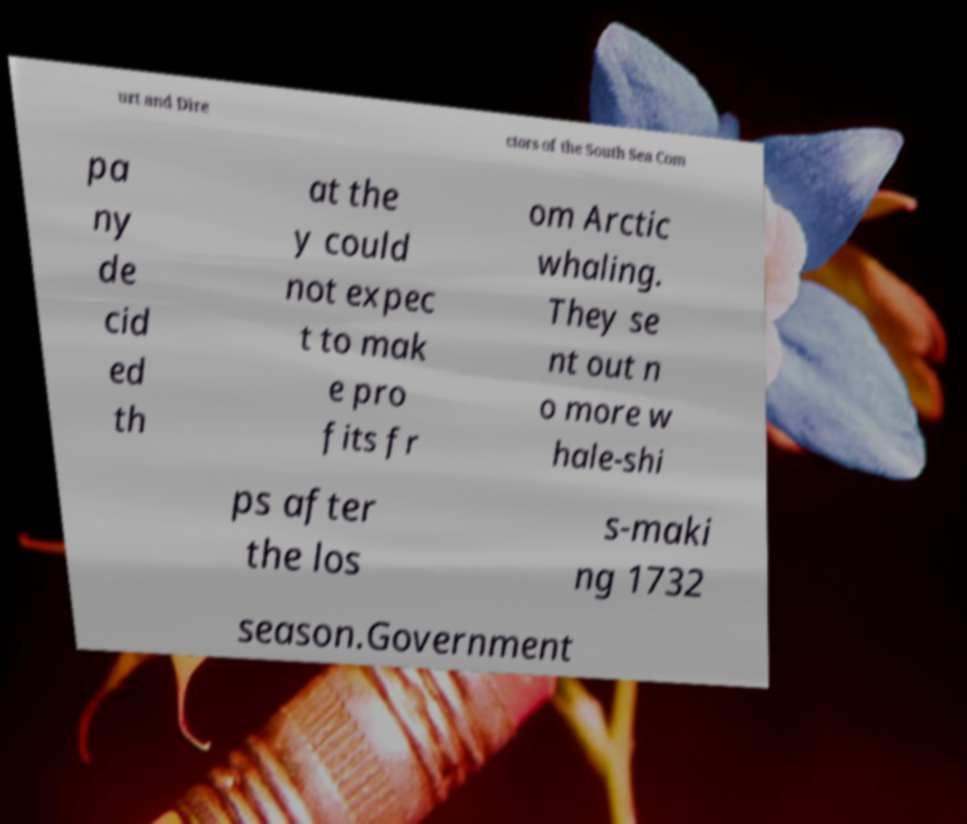What messages or text are displayed in this image? I need them in a readable, typed format. urt and Dire ctors of the South Sea Com pa ny de cid ed th at the y could not expec t to mak e pro fits fr om Arctic whaling. They se nt out n o more w hale-shi ps after the los s-maki ng 1732 season.Government 